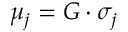Convert formula to latex. <formula><loc_0><loc_0><loc_500><loc_500>\mu _ { j } = G \cdot \sigma _ { j }</formula> 